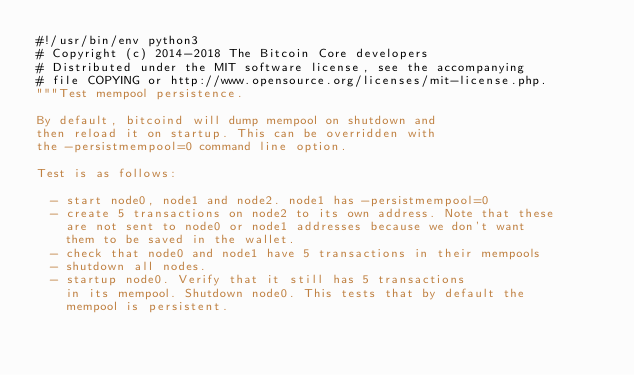Convert code to text. <code><loc_0><loc_0><loc_500><loc_500><_Python_>#!/usr/bin/env python3
# Copyright (c) 2014-2018 The Bitcoin Core developers
# Distributed under the MIT software license, see the accompanying
# file COPYING or http://www.opensource.org/licenses/mit-license.php.
"""Test mempool persistence.

By default, bitcoind will dump mempool on shutdown and
then reload it on startup. This can be overridden with
the -persistmempool=0 command line option.

Test is as follows:

  - start node0, node1 and node2. node1 has -persistmempool=0
  - create 5 transactions on node2 to its own address. Note that these
    are not sent to node0 or node1 addresses because we don't want
    them to be saved in the wallet.
  - check that node0 and node1 have 5 transactions in their mempools
  - shutdown all nodes.
  - startup node0. Verify that it still has 5 transactions
    in its mempool. Shutdown node0. This tests that by default the
    mempool is persistent.</code> 